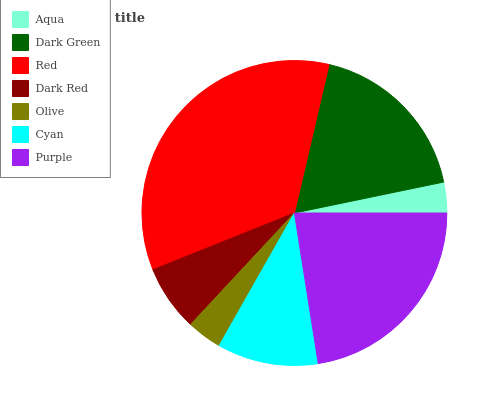Is Aqua the minimum?
Answer yes or no. Yes. Is Red the maximum?
Answer yes or no. Yes. Is Dark Green the minimum?
Answer yes or no. No. Is Dark Green the maximum?
Answer yes or no. No. Is Dark Green greater than Aqua?
Answer yes or no. Yes. Is Aqua less than Dark Green?
Answer yes or no. Yes. Is Aqua greater than Dark Green?
Answer yes or no. No. Is Dark Green less than Aqua?
Answer yes or no. No. Is Cyan the high median?
Answer yes or no. Yes. Is Cyan the low median?
Answer yes or no. Yes. Is Olive the high median?
Answer yes or no. No. Is Dark Red the low median?
Answer yes or no. No. 